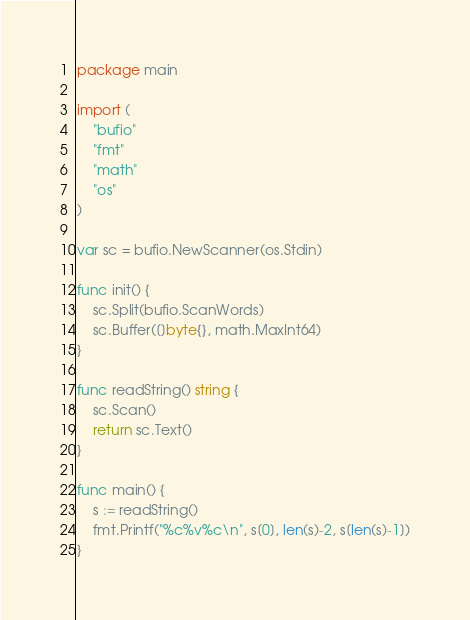Convert code to text. <code><loc_0><loc_0><loc_500><loc_500><_Go_>package main

import (
	"bufio"
	"fmt"
	"math"
	"os"
)

var sc = bufio.NewScanner(os.Stdin)

func init() {
	sc.Split(bufio.ScanWords)
	sc.Buffer([]byte{}, math.MaxInt64)
}

func readString() string {
	sc.Scan()
	return sc.Text()
}

func main() {
	s := readString()
	fmt.Printf("%c%v%c\n", s[0], len(s)-2, s[len(s)-1])
}
</code> 